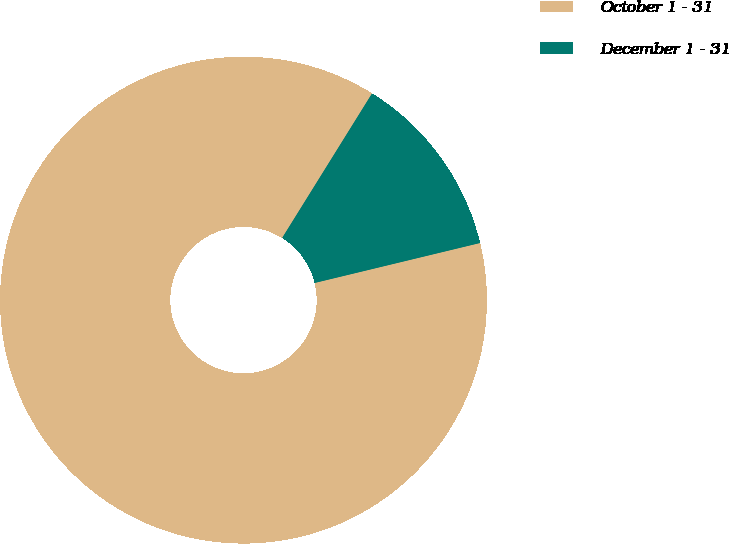Convert chart. <chart><loc_0><loc_0><loc_500><loc_500><pie_chart><fcel>October 1 - 31<fcel>December 1 - 31<nl><fcel>87.63%<fcel>12.37%<nl></chart> 